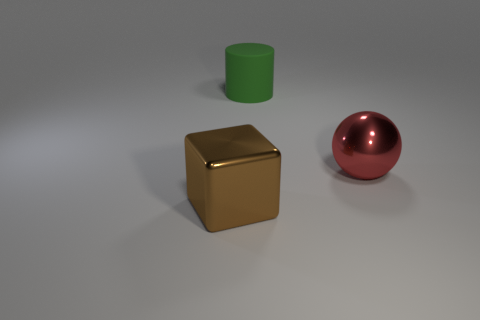What size is the red metal object on the right side of the green matte cylinder behind the ball?
Your answer should be very brief. Large. What number of cylinders are either red objects or large green matte things?
Offer a terse response. 1. There is a shiny object that is the same size as the block; what color is it?
Ensure brevity in your answer.  Red. There is a thing that is to the left of the thing behind the large metallic ball; what shape is it?
Offer a very short reply. Cube. Is the size of the thing behind the shiny ball the same as the brown metallic cube?
Your answer should be compact. Yes. How many other objects are there of the same material as the red object?
Provide a short and direct response. 1. What number of brown things are big metallic things or big matte things?
Your answer should be very brief. 1. How many large matte things are in front of the red sphere?
Keep it short and to the point. 0. How big is the shiny thing behind the shiny thing left of the large metal thing behind the big brown shiny object?
Your answer should be very brief. Large. There is a large metallic thing to the left of the big shiny thing on the right side of the big cylinder; is there a sphere right of it?
Offer a very short reply. Yes. 